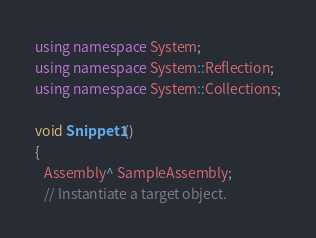Convert code to text. <code><loc_0><loc_0><loc_500><loc_500><_C++_>using namespace System;
using namespace System::Reflection;
using namespace System::Collections;

void Snippet1()
{
   Assembly^ SampleAssembly;
   // Instantiate a target object.</code> 